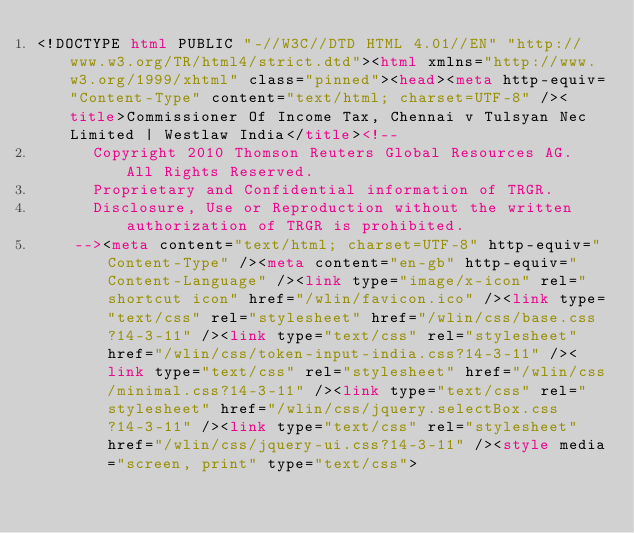Convert code to text. <code><loc_0><loc_0><loc_500><loc_500><_HTML_><!DOCTYPE html PUBLIC "-//W3C//DTD HTML 4.01//EN" "http://www.w3.org/TR/html4/strict.dtd"><html xmlns="http://www.w3.org/1999/xhtml" class="pinned"><head><meta http-equiv="Content-Type" content="text/html; charset=UTF-8" /><title>Commissioner Of Income Tax, Chennai v Tulsyan Nec Limited | Westlaw India</title><!--
      Copyright 2010 Thomson Reuters Global Resources AG. All Rights Reserved.
      Proprietary and Confidential information of TRGR.
      Disclosure, Use or Reproduction without the written authorization of TRGR is prohibited.
    --><meta content="text/html; charset=UTF-8" http-equiv="Content-Type" /><meta content="en-gb" http-equiv="Content-Language" /><link type="image/x-icon" rel="shortcut icon" href="/wlin/favicon.ico" /><link type="text/css" rel="stylesheet" href="/wlin/css/base.css?14-3-11" /><link type="text/css" rel="stylesheet" href="/wlin/css/token-input-india.css?14-3-11" /><link type="text/css" rel="stylesheet" href="/wlin/css/minimal.css?14-3-11" /><link type="text/css" rel="stylesheet" href="/wlin/css/jquery.selectBox.css?14-3-11" /><link type="text/css" rel="stylesheet" href="/wlin/css/jquery-ui.css?14-3-11" /><style media="screen, print" type="text/css"></code> 